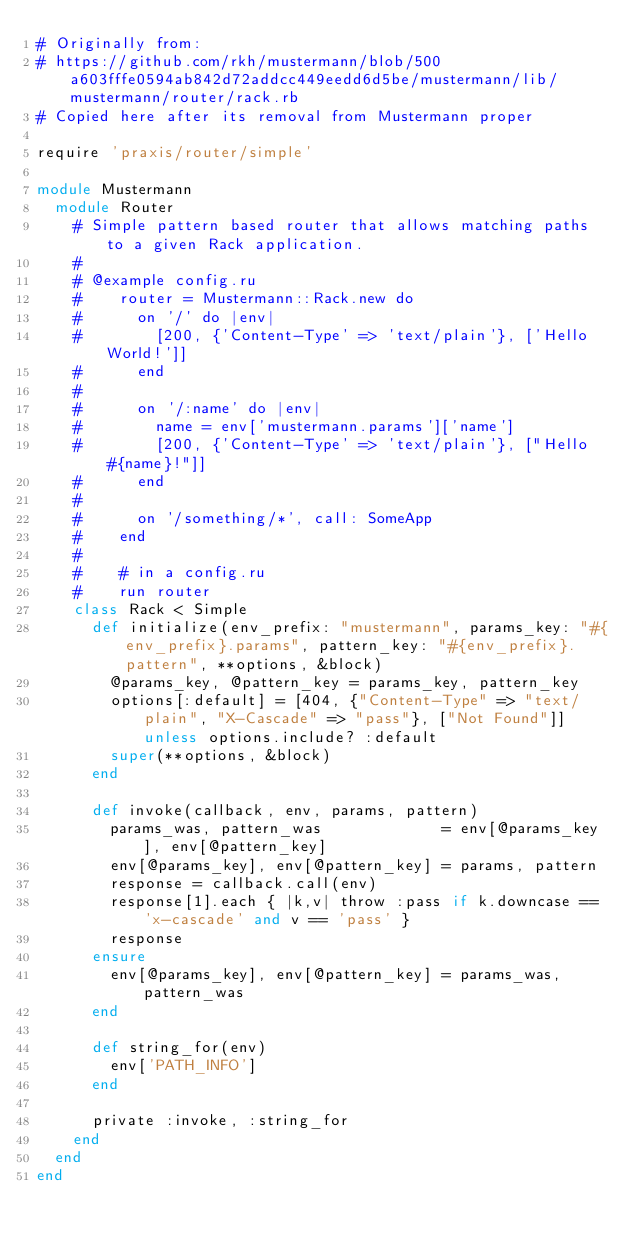Convert code to text. <code><loc_0><loc_0><loc_500><loc_500><_Ruby_># Originally from:
# https://github.com/rkh/mustermann/blob/500a603fffe0594ab842d72addcc449eedd6d5be/mustermann/lib/mustermann/router/rack.rb
# Copied here after its removal from Mustermann proper

require 'praxis/router/simple'

module Mustermann
  module Router
    # Simple pattern based router that allows matching paths to a given Rack application.
    #
    # @example config.ru
    #    router = Mustermann::Rack.new do
    #      on '/' do |env|
    #        [200, {'Content-Type' => 'text/plain'}, ['Hello World!']]
    #      end
    #
    #      on '/:name' do |env|
    #        name = env['mustermann.params']['name']
    #        [200, {'Content-Type' => 'text/plain'}, ["Hello #{name}!"]]
    #      end
    #
    #      on '/something/*', call: SomeApp
    #    end
    #
    #    # in a config.ru
    #    run router
    class Rack < Simple
      def initialize(env_prefix: "mustermann", params_key: "#{env_prefix}.params", pattern_key: "#{env_prefix}.pattern", **options, &block)
        @params_key, @pattern_key = params_key, pattern_key
        options[:default] = [404, {"Content-Type" => "text/plain", "X-Cascade" => "pass"}, ["Not Found"]] unless options.include? :default
        super(**options, &block)
      end

      def invoke(callback, env, params, pattern)
        params_was, pattern_was             = env[@params_key], env[@pattern_key]
        env[@params_key], env[@pattern_key] = params, pattern
        response = callback.call(env)
        response[1].each { |k,v| throw :pass if k.downcase == 'x-cascade' and v == 'pass' }
        response
      ensure
        env[@params_key], env[@pattern_key] = params_was, pattern_was
      end

      def string_for(env)
        env['PATH_INFO']
      end

      private :invoke, :string_for
    end
  end
end
</code> 